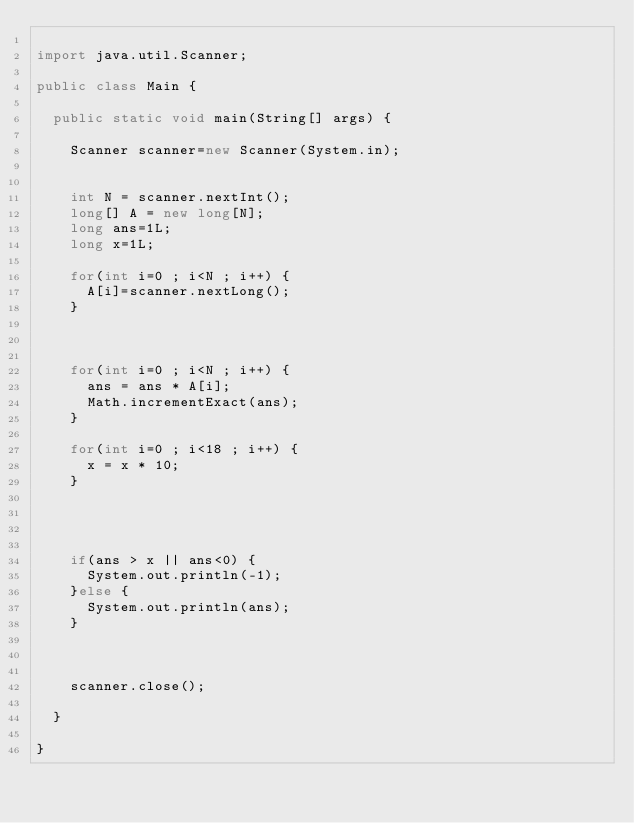<code> <loc_0><loc_0><loc_500><loc_500><_Java_>
import java.util.Scanner;

public class Main {

	public static void main(String[] args) {

		Scanner scanner=new Scanner(System.in);


		int N = scanner.nextInt();
		long[] A = new long[N];
		long ans=1L;
		long x=1L;

		for(int i=0 ; i<N ; i++) {
			A[i]=scanner.nextLong();
		}



		for(int i=0 ; i<N ; i++) {
			ans = ans * A[i];
			Math.incrementExact(ans);
		}

		for(int i=0 ; i<18 ; i++) {
			x = x * 10;
		}




		if(ans > x || ans<0) {
			System.out.println(-1);
		}else {
			System.out.println(ans);
		}



		scanner.close();

	}

}
</code> 